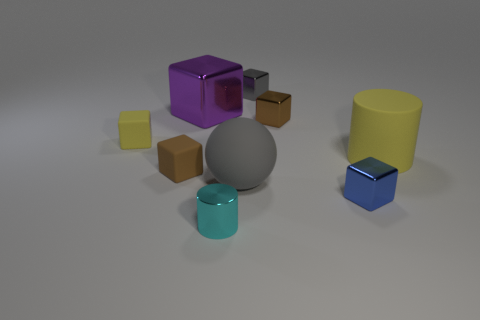What could be the function of the collection of objects in this image? These objects seem to be a random assortment of geometric shapes and do not have an inherent function as they are. However, they could be used for various purposes like educational tools to teach about shapes and volumes or as decorative items to add modern aesthetic to a space. Which object do you think stands out the most? The purple cube stands out the most due to its vibrant color and central placement within the composition, acting as a focal point among the various shapes and colors. 